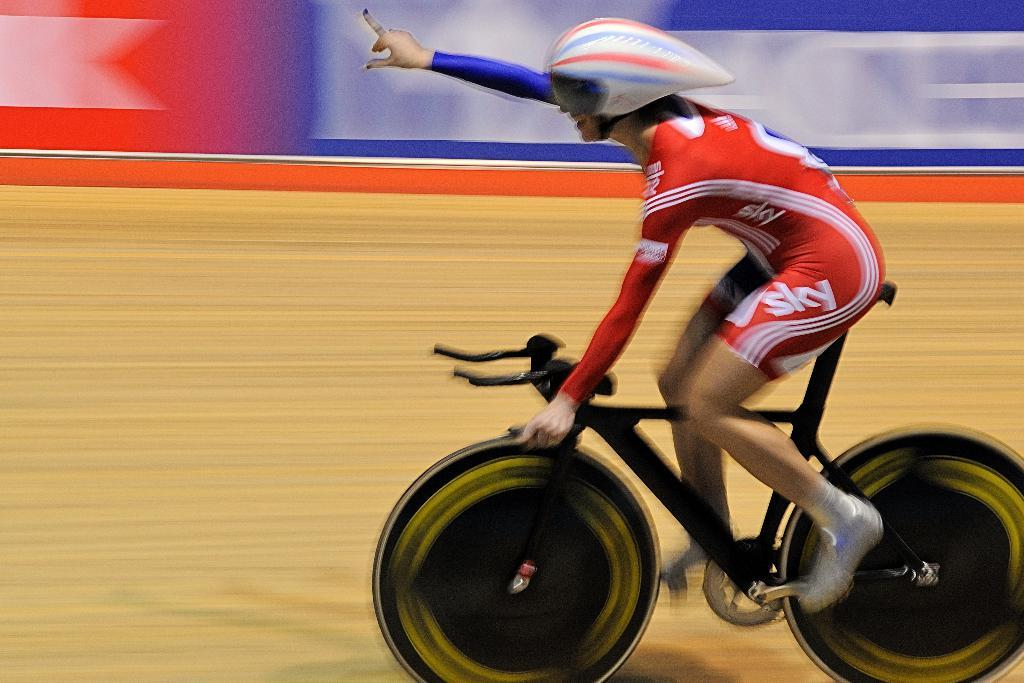Provide a one-sentence caption for the provided image. A bicycle racer wearing sky uniform does his no 1 finger gesture as he races. 